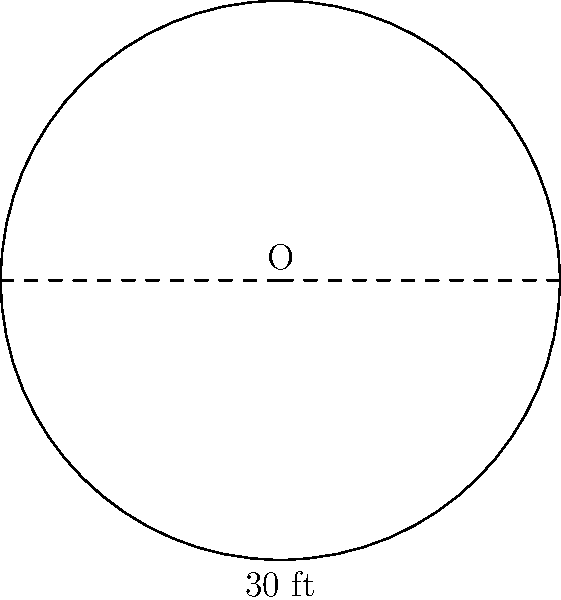As a risk-averse investor looking to diversify into real estate, you're considering a property with a unique circular driveway. The diameter of this driveway is 30 feet. What is the circumference of the driveway, rounded to the nearest foot? To find the circumference of the circular driveway, we can use the formula:

$$C = \pi d$$

Where:
$C$ = circumference
$\pi$ = pi (approximately 3.14159)
$d$ = diameter

Given:
$d = 30$ feet

Step 1: Substitute the known values into the formula:
$$C = \pi \times 30$$

Step 2: Calculate the result:
$$C = 3.14159 \times 30 = 94.24770 \text{ feet}$$

Step 3: Round to the nearest foot:
$$C \approx 94 \text{ feet}$$

This result provides a precise measurement for the driveway, which is crucial for estimating materials, maintenance costs, and potential property value - all important factors for a risk-averse real estate investor.
Answer: 94 feet 